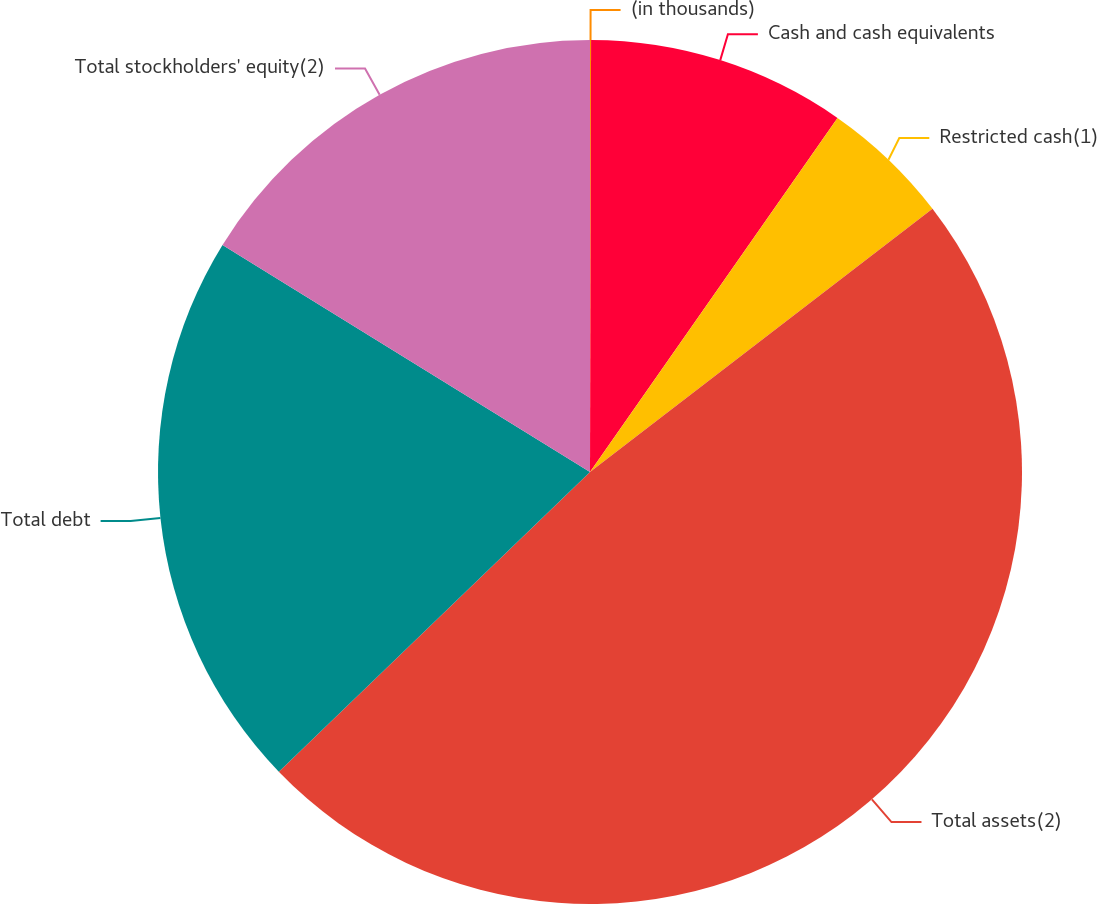Convert chart to OTSL. <chart><loc_0><loc_0><loc_500><loc_500><pie_chart><fcel>(in thousands)<fcel>Cash and cash equivalents<fcel>Restricted cash(1)<fcel>Total assets(2)<fcel>Total debt<fcel>Total stockholders' equity(2)<nl><fcel>0.04%<fcel>9.67%<fcel>4.86%<fcel>48.23%<fcel>21.01%<fcel>16.19%<nl></chart> 